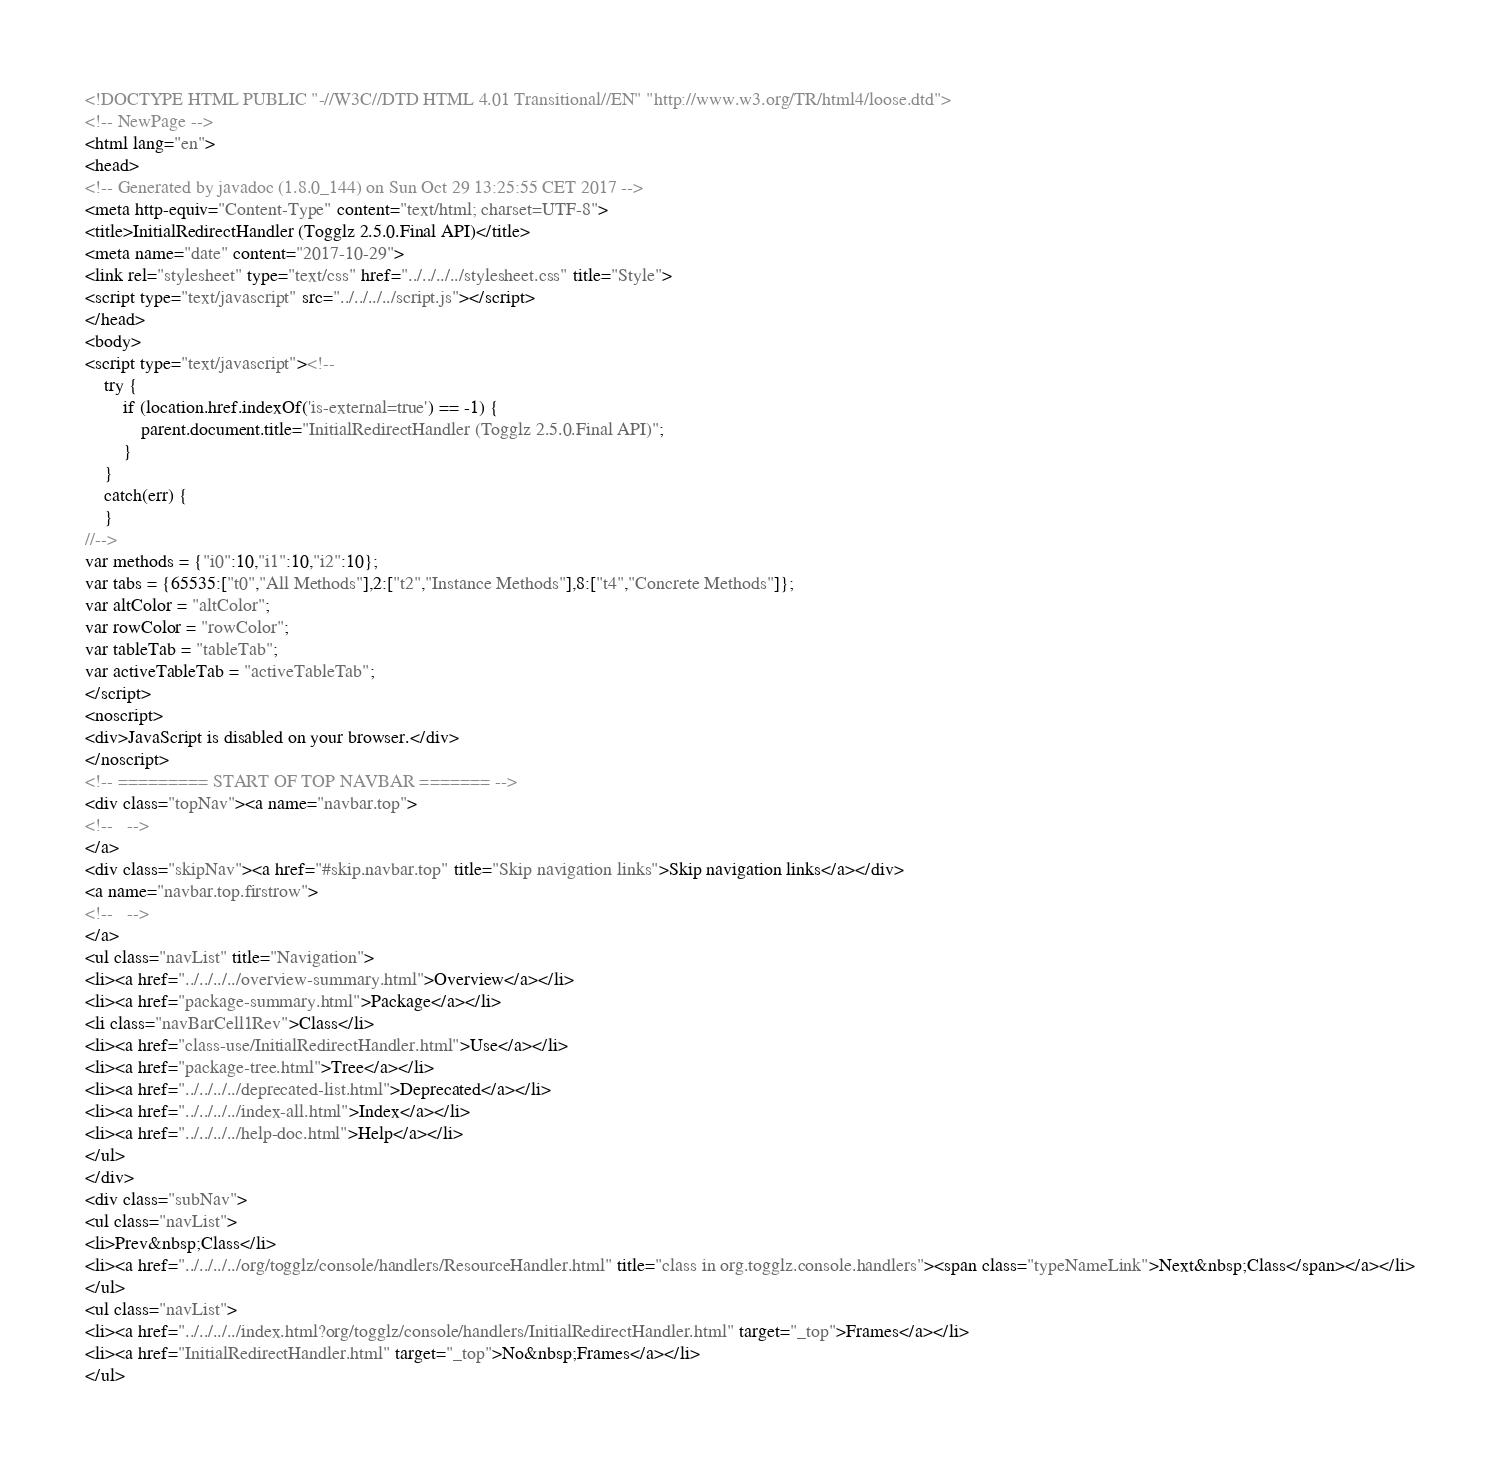Convert code to text. <code><loc_0><loc_0><loc_500><loc_500><_HTML_><!DOCTYPE HTML PUBLIC "-//W3C//DTD HTML 4.01 Transitional//EN" "http://www.w3.org/TR/html4/loose.dtd">
<!-- NewPage -->
<html lang="en">
<head>
<!-- Generated by javadoc (1.8.0_144) on Sun Oct 29 13:25:55 CET 2017 -->
<meta http-equiv="Content-Type" content="text/html; charset=UTF-8">
<title>InitialRedirectHandler (Togglz 2.5.0.Final API)</title>
<meta name="date" content="2017-10-29">
<link rel="stylesheet" type="text/css" href="../../../../stylesheet.css" title="Style">
<script type="text/javascript" src="../../../../script.js"></script>
</head>
<body>
<script type="text/javascript"><!--
    try {
        if (location.href.indexOf('is-external=true') == -1) {
            parent.document.title="InitialRedirectHandler (Togglz 2.5.0.Final API)";
        }
    }
    catch(err) {
    }
//-->
var methods = {"i0":10,"i1":10,"i2":10};
var tabs = {65535:["t0","All Methods"],2:["t2","Instance Methods"],8:["t4","Concrete Methods"]};
var altColor = "altColor";
var rowColor = "rowColor";
var tableTab = "tableTab";
var activeTableTab = "activeTableTab";
</script>
<noscript>
<div>JavaScript is disabled on your browser.</div>
</noscript>
<!-- ========= START OF TOP NAVBAR ======= -->
<div class="topNav"><a name="navbar.top">
<!--   -->
</a>
<div class="skipNav"><a href="#skip.navbar.top" title="Skip navigation links">Skip navigation links</a></div>
<a name="navbar.top.firstrow">
<!--   -->
</a>
<ul class="navList" title="Navigation">
<li><a href="../../../../overview-summary.html">Overview</a></li>
<li><a href="package-summary.html">Package</a></li>
<li class="navBarCell1Rev">Class</li>
<li><a href="class-use/InitialRedirectHandler.html">Use</a></li>
<li><a href="package-tree.html">Tree</a></li>
<li><a href="../../../../deprecated-list.html">Deprecated</a></li>
<li><a href="../../../../index-all.html">Index</a></li>
<li><a href="../../../../help-doc.html">Help</a></li>
</ul>
</div>
<div class="subNav">
<ul class="navList">
<li>Prev&nbsp;Class</li>
<li><a href="../../../../org/togglz/console/handlers/ResourceHandler.html" title="class in org.togglz.console.handlers"><span class="typeNameLink">Next&nbsp;Class</span></a></li>
</ul>
<ul class="navList">
<li><a href="../../../../index.html?org/togglz/console/handlers/InitialRedirectHandler.html" target="_top">Frames</a></li>
<li><a href="InitialRedirectHandler.html" target="_top">No&nbsp;Frames</a></li>
</ul></code> 